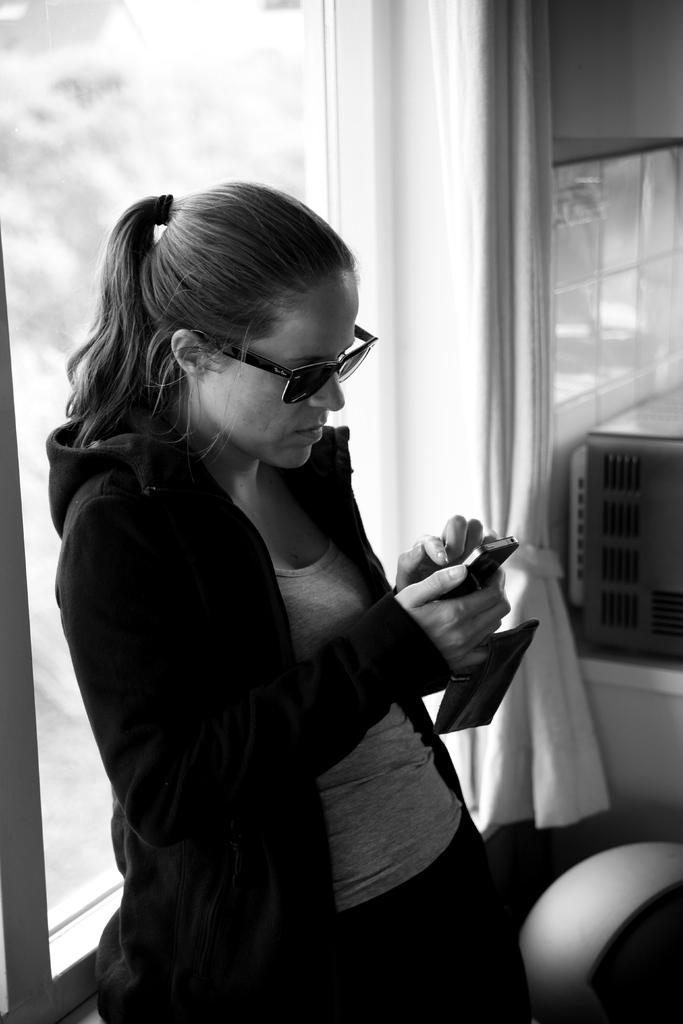What is the color scheme of the image? The image is black and white. Who is present in the image? There is a woman in the image. What is the woman wearing? The woman is wearing a jacket and goggles. What is the woman doing in the image? The woman is looking at her mobile. What can be seen behind the woman? There is a window behind the woman. Is there any window treatment present in the image? Yes, there is a curtain associated with the window. What type of business is the woman running in the image? There is no indication of a business in the image; it only shows a woman wearing a jacket, goggles, and looking at her mobile. Can you tell me how many hours the woman has slept based on the image? There is no information about the woman's sleep in the image; it only shows her looking at her mobile. 